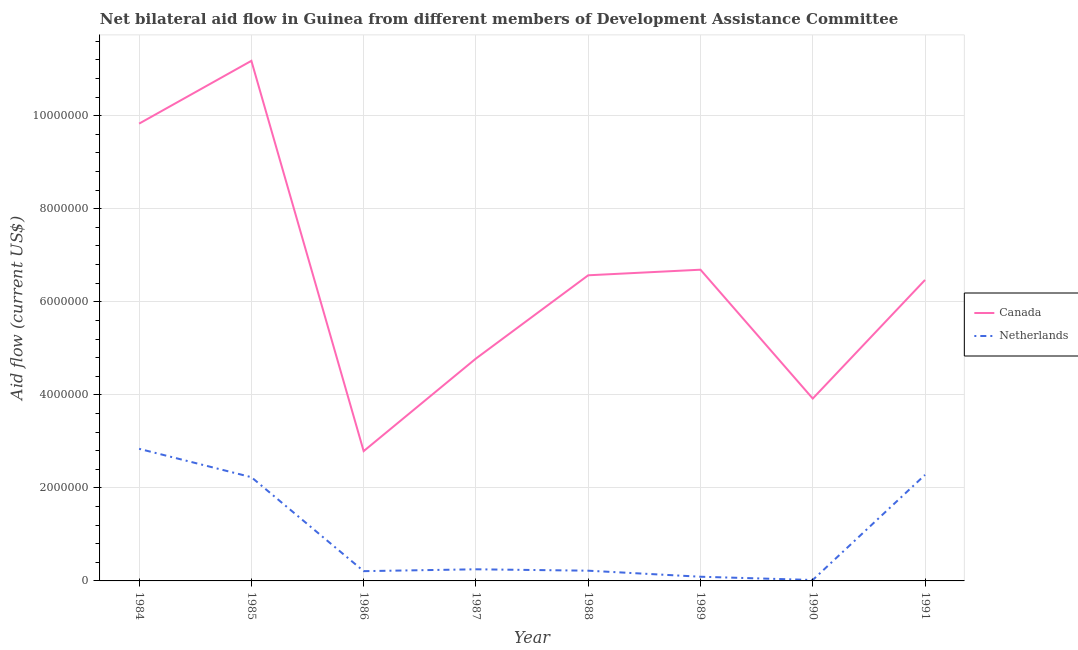Does the line corresponding to amount of aid given by netherlands intersect with the line corresponding to amount of aid given by canada?
Offer a terse response. No. What is the amount of aid given by canada in 1988?
Provide a short and direct response. 6.57e+06. Across all years, what is the maximum amount of aid given by netherlands?
Provide a succinct answer. 2.84e+06. Across all years, what is the minimum amount of aid given by canada?
Give a very brief answer. 2.79e+06. In which year was the amount of aid given by canada maximum?
Your answer should be compact. 1985. In which year was the amount of aid given by canada minimum?
Keep it short and to the point. 1986. What is the total amount of aid given by netherlands in the graph?
Provide a succinct answer. 8.14e+06. What is the difference between the amount of aid given by netherlands in 1988 and that in 1991?
Provide a short and direct response. -2.06e+06. What is the difference between the amount of aid given by canada in 1986 and the amount of aid given by netherlands in 1990?
Your response must be concise. 2.77e+06. What is the average amount of aid given by netherlands per year?
Provide a succinct answer. 1.02e+06. In the year 1987, what is the difference between the amount of aid given by netherlands and amount of aid given by canada?
Provide a succinct answer. -4.53e+06. In how many years, is the amount of aid given by canada greater than 6400000 US$?
Provide a short and direct response. 5. What is the ratio of the amount of aid given by netherlands in 1987 to that in 1988?
Provide a short and direct response. 1.14. What is the difference between the highest and the second highest amount of aid given by netherlands?
Ensure brevity in your answer.  5.60e+05. What is the difference between the highest and the lowest amount of aid given by netherlands?
Your answer should be very brief. 2.82e+06. In how many years, is the amount of aid given by canada greater than the average amount of aid given by canada taken over all years?
Your response must be concise. 4. Is the sum of the amount of aid given by netherlands in 1987 and 1990 greater than the maximum amount of aid given by canada across all years?
Your response must be concise. No. Is the amount of aid given by netherlands strictly greater than the amount of aid given by canada over the years?
Provide a short and direct response. No. Is the amount of aid given by netherlands strictly less than the amount of aid given by canada over the years?
Your answer should be compact. Yes. How many lines are there?
Offer a very short reply. 2. How many years are there in the graph?
Offer a terse response. 8. What is the difference between two consecutive major ticks on the Y-axis?
Your answer should be very brief. 2.00e+06. Does the graph contain grids?
Give a very brief answer. Yes. Where does the legend appear in the graph?
Ensure brevity in your answer.  Center right. How many legend labels are there?
Provide a short and direct response. 2. How are the legend labels stacked?
Your answer should be compact. Vertical. What is the title of the graph?
Provide a short and direct response. Net bilateral aid flow in Guinea from different members of Development Assistance Committee. What is the label or title of the X-axis?
Provide a succinct answer. Year. What is the label or title of the Y-axis?
Provide a short and direct response. Aid flow (current US$). What is the Aid flow (current US$) in Canada in 1984?
Provide a succinct answer. 9.83e+06. What is the Aid flow (current US$) in Netherlands in 1984?
Offer a terse response. 2.84e+06. What is the Aid flow (current US$) of Canada in 1985?
Your answer should be compact. 1.12e+07. What is the Aid flow (current US$) in Netherlands in 1985?
Give a very brief answer. 2.23e+06. What is the Aid flow (current US$) in Canada in 1986?
Ensure brevity in your answer.  2.79e+06. What is the Aid flow (current US$) of Netherlands in 1986?
Your answer should be compact. 2.10e+05. What is the Aid flow (current US$) in Canada in 1987?
Provide a succinct answer. 4.78e+06. What is the Aid flow (current US$) in Canada in 1988?
Offer a very short reply. 6.57e+06. What is the Aid flow (current US$) of Canada in 1989?
Provide a succinct answer. 6.69e+06. What is the Aid flow (current US$) of Netherlands in 1989?
Your answer should be very brief. 9.00e+04. What is the Aid flow (current US$) in Canada in 1990?
Provide a succinct answer. 3.92e+06. What is the Aid flow (current US$) in Netherlands in 1990?
Your response must be concise. 2.00e+04. What is the Aid flow (current US$) in Canada in 1991?
Your answer should be very brief. 6.47e+06. What is the Aid flow (current US$) of Netherlands in 1991?
Offer a terse response. 2.28e+06. Across all years, what is the maximum Aid flow (current US$) in Canada?
Keep it short and to the point. 1.12e+07. Across all years, what is the maximum Aid flow (current US$) of Netherlands?
Your answer should be very brief. 2.84e+06. Across all years, what is the minimum Aid flow (current US$) of Canada?
Offer a very short reply. 2.79e+06. What is the total Aid flow (current US$) of Canada in the graph?
Your answer should be very brief. 5.22e+07. What is the total Aid flow (current US$) in Netherlands in the graph?
Provide a short and direct response. 8.14e+06. What is the difference between the Aid flow (current US$) of Canada in 1984 and that in 1985?
Ensure brevity in your answer.  -1.35e+06. What is the difference between the Aid flow (current US$) of Canada in 1984 and that in 1986?
Offer a terse response. 7.04e+06. What is the difference between the Aid flow (current US$) in Netherlands in 1984 and that in 1986?
Give a very brief answer. 2.63e+06. What is the difference between the Aid flow (current US$) in Canada in 1984 and that in 1987?
Ensure brevity in your answer.  5.05e+06. What is the difference between the Aid flow (current US$) of Netherlands in 1984 and that in 1987?
Provide a short and direct response. 2.59e+06. What is the difference between the Aid flow (current US$) of Canada in 1984 and that in 1988?
Your response must be concise. 3.26e+06. What is the difference between the Aid flow (current US$) in Netherlands in 1984 and that in 1988?
Make the answer very short. 2.62e+06. What is the difference between the Aid flow (current US$) of Canada in 1984 and that in 1989?
Ensure brevity in your answer.  3.14e+06. What is the difference between the Aid flow (current US$) in Netherlands in 1984 and that in 1989?
Offer a very short reply. 2.75e+06. What is the difference between the Aid flow (current US$) of Canada in 1984 and that in 1990?
Your answer should be compact. 5.91e+06. What is the difference between the Aid flow (current US$) of Netherlands in 1984 and that in 1990?
Offer a terse response. 2.82e+06. What is the difference between the Aid flow (current US$) of Canada in 1984 and that in 1991?
Keep it short and to the point. 3.36e+06. What is the difference between the Aid flow (current US$) of Netherlands in 1984 and that in 1991?
Provide a short and direct response. 5.60e+05. What is the difference between the Aid flow (current US$) in Canada in 1985 and that in 1986?
Make the answer very short. 8.39e+06. What is the difference between the Aid flow (current US$) of Netherlands in 1985 and that in 1986?
Provide a short and direct response. 2.02e+06. What is the difference between the Aid flow (current US$) in Canada in 1985 and that in 1987?
Keep it short and to the point. 6.40e+06. What is the difference between the Aid flow (current US$) of Netherlands in 1985 and that in 1987?
Offer a terse response. 1.98e+06. What is the difference between the Aid flow (current US$) in Canada in 1985 and that in 1988?
Ensure brevity in your answer.  4.61e+06. What is the difference between the Aid flow (current US$) in Netherlands in 1985 and that in 1988?
Provide a short and direct response. 2.01e+06. What is the difference between the Aid flow (current US$) in Canada in 1985 and that in 1989?
Offer a terse response. 4.49e+06. What is the difference between the Aid flow (current US$) in Netherlands in 1985 and that in 1989?
Your answer should be compact. 2.14e+06. What is the difference between the Aid flow (current US$) of Canada in 1985 and that in 1990?
Offer a terse response. 7.26e+06. What is the difference between the Aid flow (current US$) of Netherlands in 1985 and that in 1990?
Your response must be concise. 2.21e+06. What is the difference between the Aid flow (current US$) of Canada in 1985 and that in 1991?
Offer a very short reply. 4.71e+06. What is the difference between the Aid flow (current US$) in Canada in 1986 and that in 1987?
Your response must be concise. -1.99e+06. What is the difference between the Aid flow (current US$) in Netherlands in 1986 and that in 1987?
Offer a very short reply. -4.00e+04. What is the difference between the Aid flow (current US$) of Canada in 1986 and that in 1988?
Your response must be concise. -3.78e+06. What is the difference between the Aid flow (current US$) of Canada in 1986 and that in 1989?
Make the answer very short. -3.90e+06. What is the difference between the Aid flow (current US$) of Canada in 1986 and that in 1990?
Offer a very short reply. -1.13e+06. What is the difference between the Aid flow (current US$) of Canada in 1986 and that in 1991?
Your answer should be compact. -3.68e+06. What is the difference between the Aid flow (current US$) of Netherlands in 1986 and that in 1991?
Make the answer very short. -2.07e+06. What is the difference between the Aid flow (current US$) in Canada in 1987 and that in 1988?
Give a very brief answer. -1.79e+06. What is the difference between the Aid flow (current US$) of Canada in 1987 and that in 1989?
Your answer should be compact. -1.91e+06. What is the difference between the Aid flow (current US$) of Netherlands in 1987 and that in 1989?
Offer a terse response. 1.60e+05. What is the difference between the Aid flow (current US$) in Canada in 1987 and that in 1990?
Ensure brevity in your answer.  8.60e+05. What is the difference between the Aid flow (current US$) of Netherlands in 1987 and that in 1990?
Offer a terse response. 2.30e+05. What is the difference between the Aid flow (current US$) of Canada in 1987 and that in 1991?
Offer a terse response. -1.69e+06. What is the difference between the Aid flow (current US$) in Netherlands in 1987 and that in 1991?
Offer a terse response. -2.03e+06. What is the difference between the Aid flow (current US$) in Canada in 1988 and that in 1989?
Offer a terse response. -1.20e+05. What is the difference between the Aid flow (current US$) in Netherlands in 1988 and that in 1989?
Offer a terse response. 1.30e+05. What is the difference between the Aid flow (current US$) of Canada in 1988 and that in 1990?
Offer a terse response. 2.65e+06. What is the difference between the Aid flow (current US$) in Netherlands in 1988 and that in 1990?
Offer a very short reply. 2.00e+05. What is the difference between the Aid flow (current US$) of Canada in 1988 and that in 1991?
Offer a terse response. 1.00e+05. What is the difference between the Aid flow (current US$) of Netherlands in 1988 and that in 1991?
Ensure brevity in your answer.  -2.06e+06. What is the difference between the Aid flow (current US$) of Canada in 1989 and that in 1990?
Give a very brief answer. 2.77e+06. What is the difference between the Aid flow (current US$) in Netherlands in 1989 and that in 1991?
Keep it short and to the point. -2.19e+06. What is the difference between the Aid flow (current US$) in Canada in 1990 and that in 1991?
Provide a succinct answer. -2.55e+06. What is the difference between the Aid flow (current US$) in Netherlands in 1990 and that in 1991?
Provide a short and direct response. -2.26e+06. What is the difference between the Aid flow (current US$) of Canada in 1984 and the Aid flow (current US$) of Netherlands in 1985?
Ensure brevity in your answer.  7.60e+06. What is the difference between the Aid flow (current US$) of Canada in 1984 and the Aid flow (current US$) of Netherlands in 1986?
Your answer should be very brief. 9.62e+06. What is the difference between the Aid flow (current US$) in Canada in 1984 and the Aid flow (current US$) in Netherlands in 1987?
Your response must be concise. 9.58e+06. What is the difference between the Aid flow (current US$) in Canada in 1984 and the Aid flow (current US$) in Netherlands in 1988?
Offer a very short reply. 9.61e+06. What is the difference between the Aid flow (current US$) in Canada in 1984 and the Aid flow (current US$) in Netherlands in 1989?
Provide a short and direct response. 9.74e+06. What is the difference between the Aid flow (current US$) of Canada in 1984 and the Aid flow (current US$) of Netherlands in 1990?
Keep it short and to the point. 9.81e+06. What is the difference between the Aid flow (current US$) of Canada in 1984 and the Aid flow (current US$) of Netherlands in 1991?
Your answer should be compact. 7.55e+06. What is the difference between the Aid flow (current US$) in Canada in 1985 and the Aid flow (current US$) in Netherlands in 1986?
Give a very brief answer. 1.10e+07. What is the difference between the Aid flow (current US$) of Canada in 1985 and the Aid flow (current US$) of Netherlands in 1987?
Make the answer very short. 1.09e+07. What is the difference between the Aid flow (current US$) of Canada in 1985 and the Aid flow (current US$) of Netherlands in 1988?
Make the answer very short. 1.10e+07. What is the difference between the Aid flow (current US$) in Canada in 1985 and the Aid flow (current US$) in Netherlands in 1989?
Ensure brevity in your answer.  1.11e+07. What is the difference between the Aid flow (current US$) of Canada in 1985 and the Aid flow (current US$) of Netherlands in 1990?
Provide a short and direct response. 1.12e+07. What is the difference between the Aid flow (current US$) in Canada in 1985 and the Aid flow (current US$) in Netherlands in 1991?
Offer a terse response. 8.90e+06. What is the difference between the Aid flow (current US$) of Canada in 1986 and the Aid flow (current US$) of Netherlands in 1987?
Make the answer very short. 2.54e+06. What is the difference between the Aid flow (current US$) in Canada in 1986 and the Aid flow (current US$) in Netherlands in 1988?
Provide a succinct answer. 2.57e+06. What is the difference between the Aid flow (current US$) in Canada in 1986 and the Aid flow (current US$) in Netherlands in 1989?
Your response must be concise. 2.70e+06. What is the difference between the Aid flow (current US$) in Canada in 1986 and the Aid flow (current US$) in Netherlands in 1990?
Offer a terse response. 2.77e+06. What is the difference between the Aid flow (current US$) of Canada in 1986 and the Aid flow (current US$) of Netherlands in 1991?
Provide a succinct answer. 5.10e+05. What is the difference between the Aid flow (current US$) in Canada in 1987 and the Aid flow (current US$) in Netherlands in 1988?
Your answer should be compact. 4.56e+06. What is the difference between the Aid flow (current US$) in Canada in 1987 and the Aid flow (current US$) in Netherlands in 1989?
Offer a terse response. 4.69e+06. What is the difference between the Aid flow (current US$) of Canada in 1987 and the Aid flow (current US$) of Netherlands in 1990?
Your answer should be very brief. 4.76e+06. What is the difference between the Aid flow (current US$) of Canada in 1987 and the Aid flow (current US$) of Netherlands in 1991?
Offer a terse response. 2.50e+06. What is the difference between the Aid flow (current US$) of Canada in 1988 and the Aid flow (current US$) of Netherlands in 1989?
Offer a very short reply. 6.48e+06. What is the difference between the Aid flow (current US$) of Canada in 1988 and the Aid flow (current US$) of Netherlands in 1990?
Your answer should be very brief. 6.55e+06. What is the difference between the Aid flow (current US$) of Canada in 1988 and the Aid flow (current US$) of Netherlands in 1991?
Give a very brief answer. 4.29e+06. What is the difference between the Aid flow (current US$) in Canada in 1989 and the Aid flow (current US$) in Netherlands in 1990?
Offer a very short reply. 6.67e+06. What is the difference between the Aid flow (current US$) in Canada in 1989 and the Aid flow (current US$) in Netherlands in 1991?
Provide a succinct answer. 4.41e+06. What is the difference between the Aid flow (current US$) in Canada in 1990 and the Aid flow (current US$) in Netherlands in 1991?
Your answer should be compact. 1.64e+06. What is the average Aid flow (current US$) in Canada per year?
Provide a short and direct response. 6.53e+06. What is the average Aid flow (current US$) of Netherlands per year?
Ensure brevity in your answer.  1.02e+06. In the year 1984, what is the difference between the Aid flow (current US$) of Canada and Aid flow (current US$) of Netherlands?
Offer a terse response. 6.99e+06. In the year 1985, what is the difference between the Aid flow (current US$) in Canada and Aid flow (current US$) in Netherlands?
Give a very brief answer. 8.95e+06. In the year 1986, what is the difference between the Aid flow (current US$) in Canada and Aid flow (current US$) in Netherlands?
Provide a succinct answer. 2.58e+06. In the year 1987, what is the difference between the Aid flow (current US$) in Canada and Aid flow (current US$) in Netherlands?
Give a very brief answer. 4.53e+06. In the year 1988, what is the difference between the Aid flow (current US$) of Canada and Aid flow (current US$) of Netherlands?
Your answer should be compact. 6.35e+06. In the year 1989, what is the difference between the Aid flow (current US$) of Canada and Aid flow (current US$) of Netherlands?
Ensure brevity in your answer.  6.60e+06. In the year 1990, what is the difference between the Aid flow (current US$) of Canada and Aid flow (current US$) of Netherlands?
Your answer should be very brief. 3.90e+06. In the year 1991, what is the difference between the Aid flow (current US$) in Canada and Aid flow (current US$) in Netherlands?
Your answer should be very brief. 4.19e+06. What is the ratio of the Aid flow (current US$) of Canada in 1984 to that in 1985?
Make the answer very short. 0.88. What is the ratio of the Aid flow (current US$) of Netherlands in 1984 to that in 1985?
Your answer should be very brief. 1.27. What is the ratio of the Aid flow (current US$) in Canada in 1984 to that in 1986?
Your answer should be compact. 3.52. What is the ratio of the Aid flow (current US$) in Netherlands in 1984 to that in 1986?
Provide a short and direct response. 13.52. What is the ratio of the Aid flow (current US$) in Canada in 1984 to that in 1987?
Keep it short and to the point. 2.06. What is the ratio of the Aid flow (current US$) of Netherlands in 1984 to that in 1987?
Give a very brief answer. 11.36. What is the ratio of the Aid flow (current US$) in Canada in 1984 to that in 1988?
Provide a short and direct response. 1.5. What is the ratio of the Aid flow (current US$) in Netherlands in 1984 to that in 1988?
Provide a short and direct response. 12.91. What is the ratio of the Aid flow (current US$) in Canada in 1984 to that in 1989?
Provide a succinct answer. 1.47. What is the ratio of the Aid flow (current US$) of Netherlands in 1984 to that in 1989?
Your response must be concise. 31.56. What is the ratio of the Aid flow (current US$) in Canada in 1984 to that in 1990?
Offer a terse response. 2.51. What is the ratio of the Aid flow (current US$) in Netherlands in 1984 to that in 1990?
Offer a terse response. 142. What is the ratio of the Aid flow (current US$) of Canada in 1984 to that in 1991?
Give a very brief answer. 1.52. What is the ratio of the Aid flow (current US$) of Netherlands in 1984 to that in 1991?
Keep it short and to the point. 1.25. What is the ratio of the Aid flow (current US$) of Canada in 1985 to that in 1986?
Provide a short and direct response. 4.01. What is the ratio of the Aid flow (current US$) in Netherlands in 1985 to that in 1986?
Provide a short and direct response. 10.62. What is the ratio of the Aid flow (current US$) of Canada in 1985 to that in 1987?
Provide a succinct answer. 2.34. What is the ratio of the Aid flow (current US$) of Netherlands in 1985 to that in 1987?
Offer a terse response. 8.92. What is the ratio of the Aid flow (current US$) of Canada in 1985 to that in 1988?
Offer a very short reply. 1.7. What is the ratio of the Aid flow (current US$) of Netherlands in 1985 to that in 1988?
Your answer should be very brief. 10.14. What is the ratio of the Aid flow (current US$) of Canada in 1985 to that in 1989?
Keep it short and to the point. 1.67. What is the ratio of the Aid flow (current US$) of Netherlands in 1985 to that in 1989?
Provide a succinct answer. 24.78. What is the ratio of the Aid flow (current US$) in Canada in 1985 to that in 1990?
Provide a short and direct response. 2.85. What is the ratio of the Aid flow (current US$) of Netherlands in 1985 to that in 1990?
Provide a short and direct response. 111.5. What is the ratio of the Aid flow (current US$) of Canada in 1985 to that in 1991?
Your answer should be compact. 1.73. What is the ratio of the Aid flow (current US$) of Netherlands in 1985 to that in 1991?
Your answer should be very brief. 0.98. What is the ratio of the Aid flow (current US$) in Canada in 1986 to that in 1987?
Offer a terse response. 0.58. What is the ratio of the Aid flow (current US$) in Netherlands in 1986 to that in 1987?
Offer a very short reply. 0.84. What is the ratio of the Aid flow (current US$) of Canada in 1986 to that in 1988?
Make the answer very short. 0.42. What is the ratio of the Aid flow (current US$) of Netherlands in 1986 to that in 1988?
Offer a terse response. 0.95. What is the ratio of the Aid flow (current US$) in Canada in 1986 to that in 1989?
Ensure brevity in your answer.  0.42. What is the ratio of the Aid flow (current US$) in Netherlands in 1986 to that in 1989?
Provide a succinct answer. 2.33. What is the ratio of the Aid flow (current US$) of Canada in 1986 to that in 1990?
Your answer should be very brief. 0.71. What is the ratio of the Aid flow (current US$) in Canada in 1986 to that in 1991?
Give a very brief answer. 0.43. What is the ratio of the Aid flow (current US$) in Netherlands in 1986 to that in 1991?
Offer a terse response. 0.09. What is the ratio of the Aid flow (current US$) in Canada in 1987 to that in 1988?
Give a very brief answer. 0.73. What is the ratio of the Aid flow (current US$) in Netherlands in 1987 to that in 1988?
Your answer should be very brief. 1.14. What is the ratio of the Aid flow (current US$) of Canada in 1987 to that in 1989?
Provide a succinct answer. 0.71. What is the ratio of the Aid flow (current US$) in Netherlands in 1987 to that in 1989?
Your answer should be very brief. 2.78. What is the ratio of the Aid flow (current US$) in Canada in 1987 to that in 1990?
Provide a succinct answer. 1.22. What is the ratio of the Aid flow (current US$) in Netherlands in 1987 to that in 1990?
Your answer should be compact. 12.5. What is the ratio of the Aid flow (current US$) in Canada in 1987 to that in 1991?
Offer a very short reply. 0.74. What is the ratio of the Aid flow (current US$) of Netherlands in 1987 to that in 1991?
Your answer should be very brief. 0.11. What is the ratio of the Aid flow (current US$) of Canada in 1988 to that in 1989?
Give a very brief answer. 0.98. What is the ratio of the Aid flow (current US$) in Netherlands in 1988 to that in 1989?
Offer a terse response. 2.44. What is the ratio of the Aid flow (current US$) of Canada in 1988 to that in 1990?
Provide a short and direct response. 1.68. What is the ratio of the Aid flow (current US$) of Netherlands in 1988 to that in 1990?
Give a very brief answer. 11. What is the ratio of the Aid flow (current US$) of Canada in 1988 to that in 1991?
Ensure brevity in your answer.  1.02. What is the ratio of the Aid flow (current US$) of Netherlands in 1988 to that in 1991?
Provide a succinct answer. 0.1. What is the ratio of the Aid flow (current US$) of Canada in 1989 to that in 1990?
Ensure brevity in your answer.  1.71. What is the ratio of the Aid flow (current US$) of Canada in 1989 to that in 1991?
Your answer should be very brief. 1.03. What is the ratio of the Aid flow (current US$) in Netherlands in 1989 to that in 1991?
Give a very brief answer. 0.04. What is the ratio of the Aid flow (current US$) of Canada in 1990 to that in 1991?
Offer a terse response. 0.61. What is the ratio of the Aid flow (current US$) in Netherlands in 1990 to that in 1991?
Ensure brevity in your answer.  0.01. What is the difference between the highest and the second highest Aid flow (current US$) of Canada?
Give a very brief answer. 1.35e+06. What is the difference between the highest and the second highest Aid flow (current US$) of Netherlands?
Offer a terse response. 5.60e+05. What is the difference between the highest and the lowest Aid flow (current US$) of Canada?
Keep it short and to the point. 8.39e+06. What is the difference between the highest and the lowest Aid flow (current US$) in Netherlands?
Give a very brief answer. 2.82e+06. 